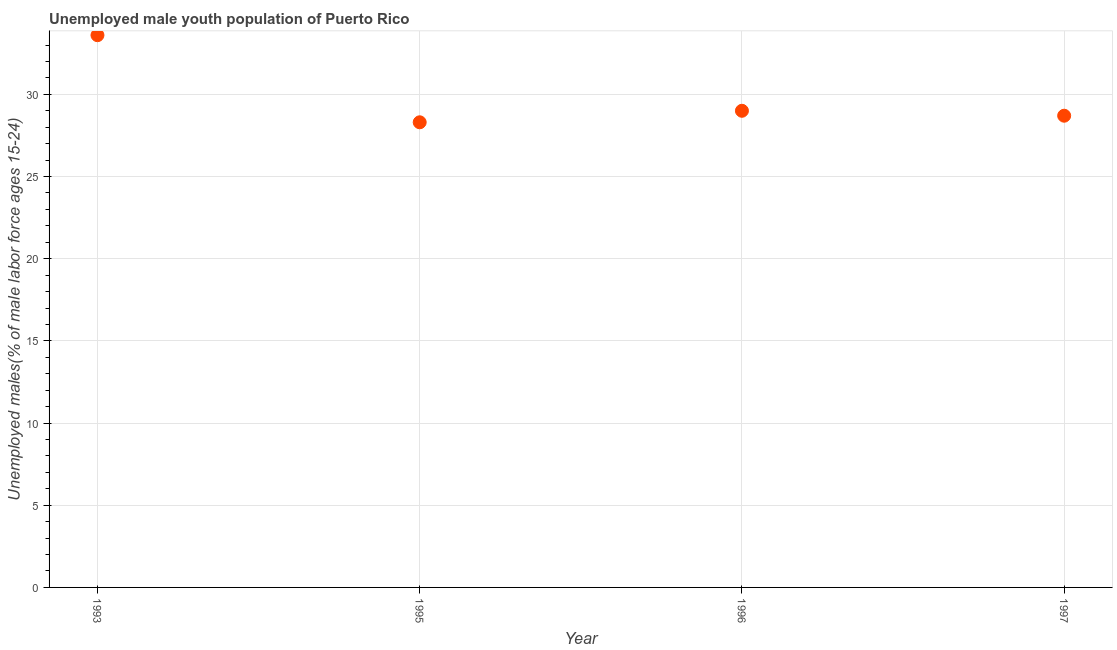What is the unemployed male youth in 1995?
Your response must be concise. 28.3. Across all years, what is the maximum unemployed male youth?
Make the answer very short. 33.6. Across all years, what is the minimum unemployed male youth?
Make the answer very short. 28.3. In which year was the unemployed male youth minimum?
Make the answer very short. 1995. What is the sum of the unemployed male youth?
Provide a succinct answer. 119.6. What is the difference between the unemployed male youth in 1993 and 1995?
Your answer should be very brief. 5.3. What is the average unemployed male youth per year?
Provide a succinct answer. 29.9. What is the median unemployed male youth?
Ensure brevity in your answer.  28.85. In how many years, is the unemployed male youth greater than 12 %?
Provide a short and direct response. 4. What is the ratio of the unemployed male youth in 1993 to that in 1997?
Make the answer very short. 1.17. What is the difference between the highest and the second highest unemployed male youth?
Offer a terse response. 4.6. Is the sum of the unemployed male youth in 1993 and 1995 greater than the maximum unemployed male youth across all years?
Keep it short and to the point. Yes. What is the difference between the highest and the lowest unemployed male youth?
Keep it short and to the point. 5.3. In how many years, is the unemployed male youth greater than the average unemployed male youth taken over all years?
Give a very brief answer. 1. Does the unemployed male youth monotonically increase over the years?
Give a very brief answer. No. What is the difference between two consecutive major ticks on the Y-axis?
Your response must be concise. 5. Does the graph contain grids?
Provide a short and direct response. Yes. What is the title of the graph?
Your answer should be very brief. Unemployed male youth population of Puerto Rico. What is the label or title of the X-axis?
Give a very brief answer. Year. What is the label or title of the Y-axis?
Provide a short and direct response. Unemployed males(% of male labor force ages 15-24). What is the Unemployed males(% of male labor force ages 15-24) in 1993?
Ensure brevity in your answer.  33.6. What is the Unemployed males(% of male labor force ages 15-24) in 1995?
Keep it short and to the point. 28.3. What is the Unemployed males(% of male labor force ages 15-24) in 1996?
Your answer should be very brief. 29. What is the Unemployed males(% of male labor force ages 15-24) in 1997?
Provide a succinct answer. 28.7. What is the difference between the Unemployed males(% of male labor force ages 15-24) in 1995 and 1996?
Your answer should be very brief. -0.7. What is the difference between the Unemployed males(% of male labor force ages 15-24) in 1996 and 1997?
Give a very brief answer. 0.3. What is the ratio of the Unemployed males(% of male labor force ages 15-24) in 1993 to that in 1995?
Offer a very short reply. 1.19. What is the ratio of the Unemployed males(% of male labor force ages 15-24) in 1993 to that in 1996?
Your answer should be very brief. 1.16. What is the ratio of the Unemployed males(% of male labor force ages 15-24) in 1993 to that in 1997?
Make the answer very short. 1.17. What is the ratio of the Unemployed males(% of male labor force ages 15-24) in 1995 to that in 1996?
Make the answer very short. 0.98. What is the ratio of the Unemployed males(% of male labor force ages 15-24) in 1995 to that in 1997?
Make the answer very short. 0.99. What is the ratio of the Unemployed males(% of male labor force ages 15-24) in 1996 to that in 1997?
Your answer should be very brief. 1.01. 